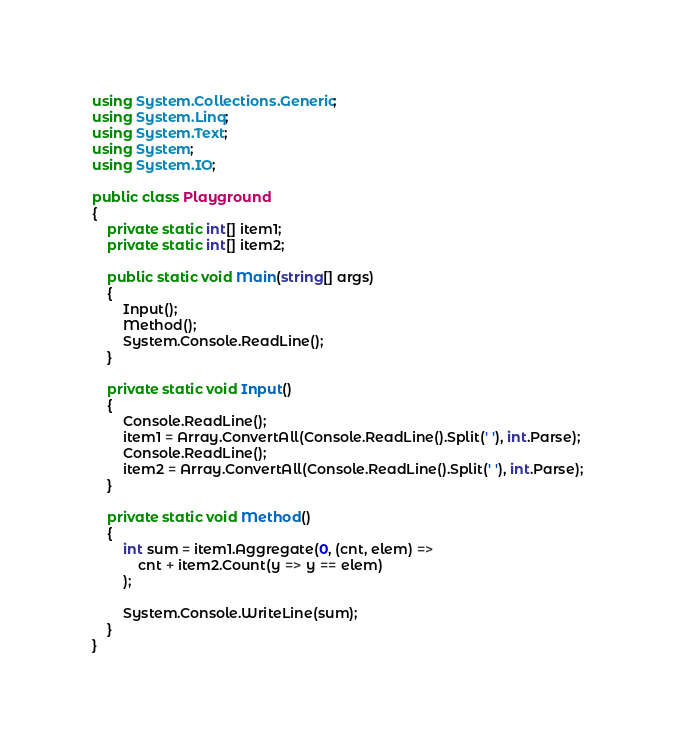Convert code to text. <code><loc_0><loc_0><loc_500><loc_500><_C#_>using System.Collections.Generic;
using System.Linq;
using System.Text;
using System;
using System.IO;

public class Playground
{
    private static int[] item1;
    private static int[] item2;

    public static void Main(string[] args)
    {
        Input();
        Method();
        System.Console.ReadLine();
    }

    private static void Input()
    {
        Console.ReadLine();
        item1 = Array.ConvertAll(Console.ReadLine().Split(' '), int.Parse);
        Console.ReadLine();
        item2 = Array.ConvertAll(Console.ReadLine().Split(' '), int.Parse);
    }

    private static void Method()
    {
        int sum = item1.Aggregate(0, (cnt, elem) =>
            cnt + item2.Count(y => y == elem)
        );

        System.Console.WriteLine(sum);
    }
}</code> 